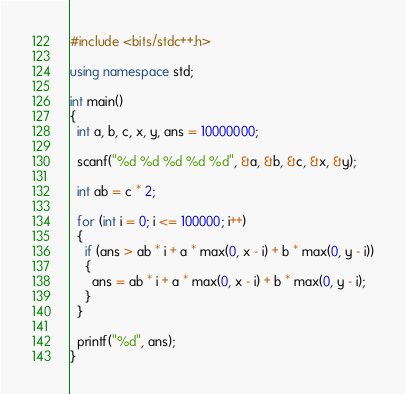Convert code to text. <code><loc_0><loc_0><loc_500><loc_500><_C++_>#include <bits/stdc++.h>

using namespace std;

int main()
{
  int a, b, c, x, y, ans = 10000000;

  scanf("%d %d %d %d %d", &a, &b, &c, &x, &y);

  int ab = c * 2;

  for (int i = 0; i <= 100000; i++)
  {
    if (ans > ab * i + a * max(0, x - i) + b * max(0, y - i))
    {
      ans = ab * i + a * max(0, x - i) + b * max(0, y - i);
    }
  }

  printf("%d", ans);
}</code> 